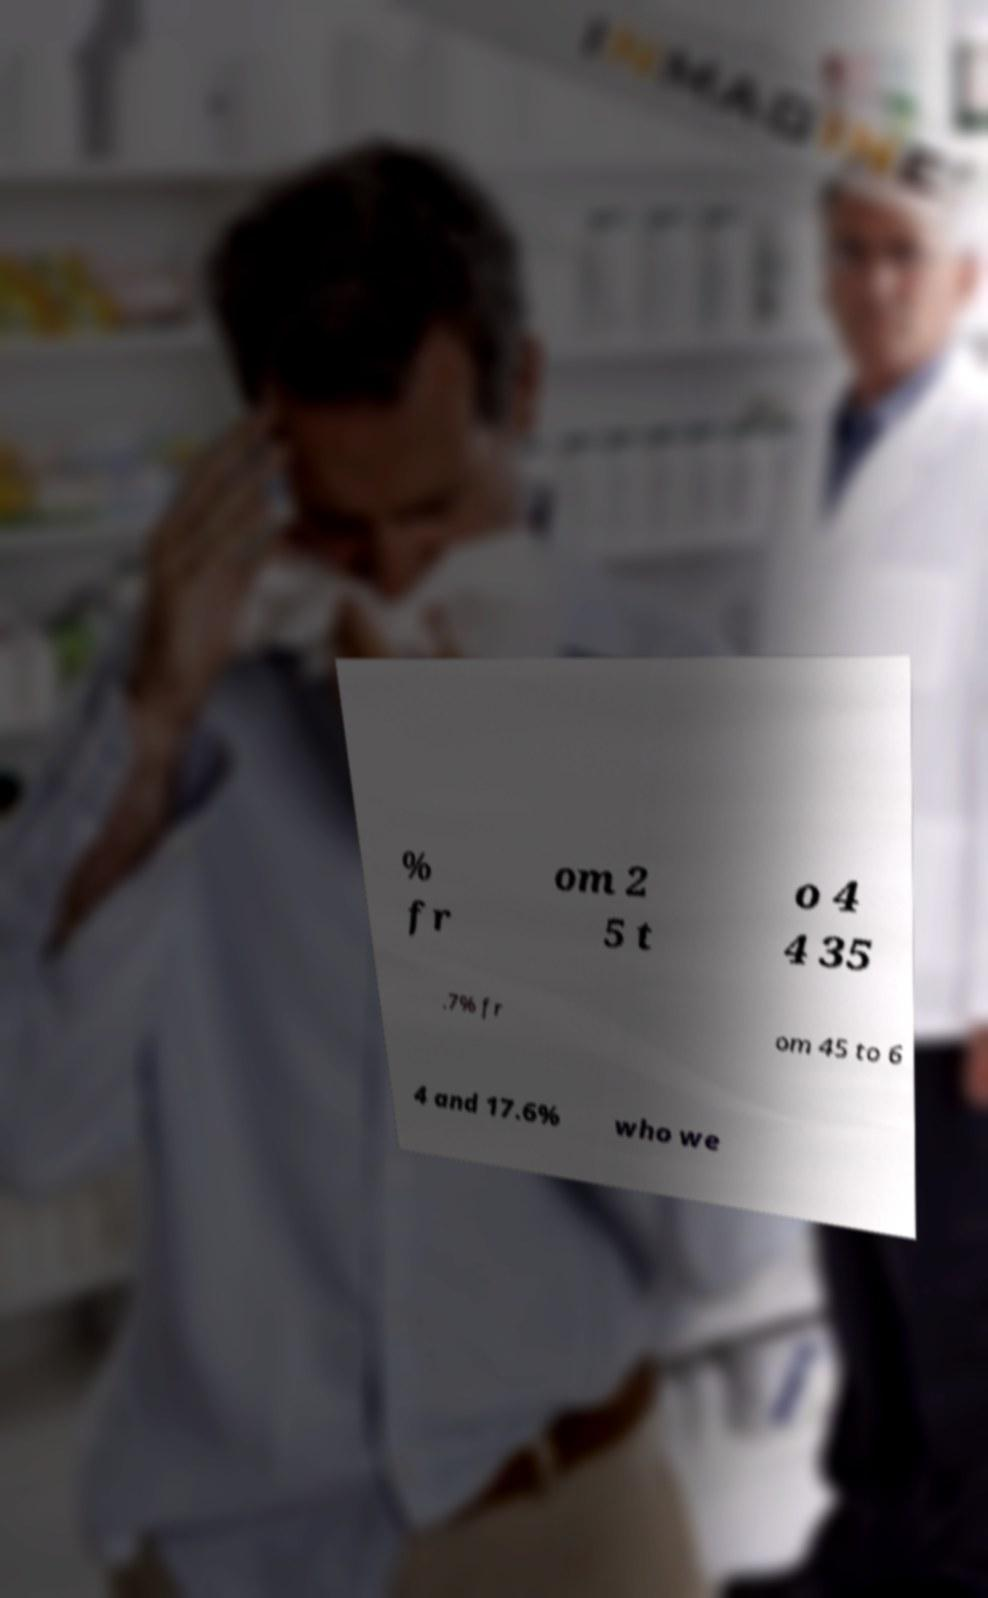Can you accurately transcribe the text from the provided image for me? % fr om 2 5 t o 4 4 35 .7% fr om 45 to 6 4 and 17.6% who we 